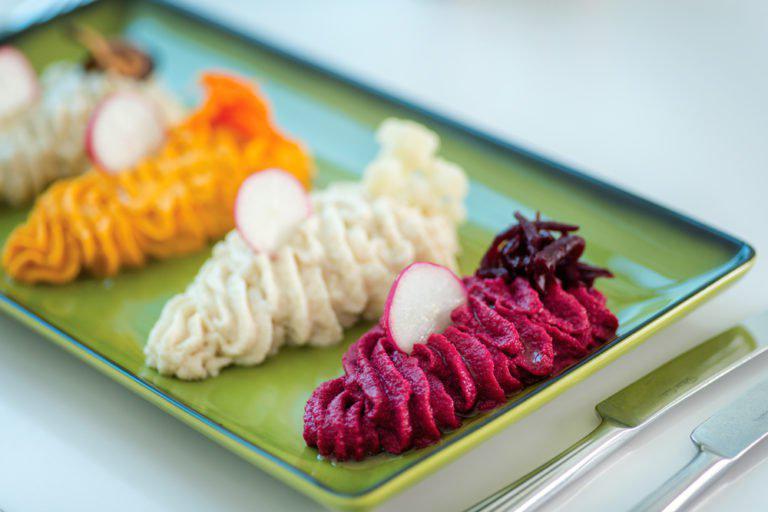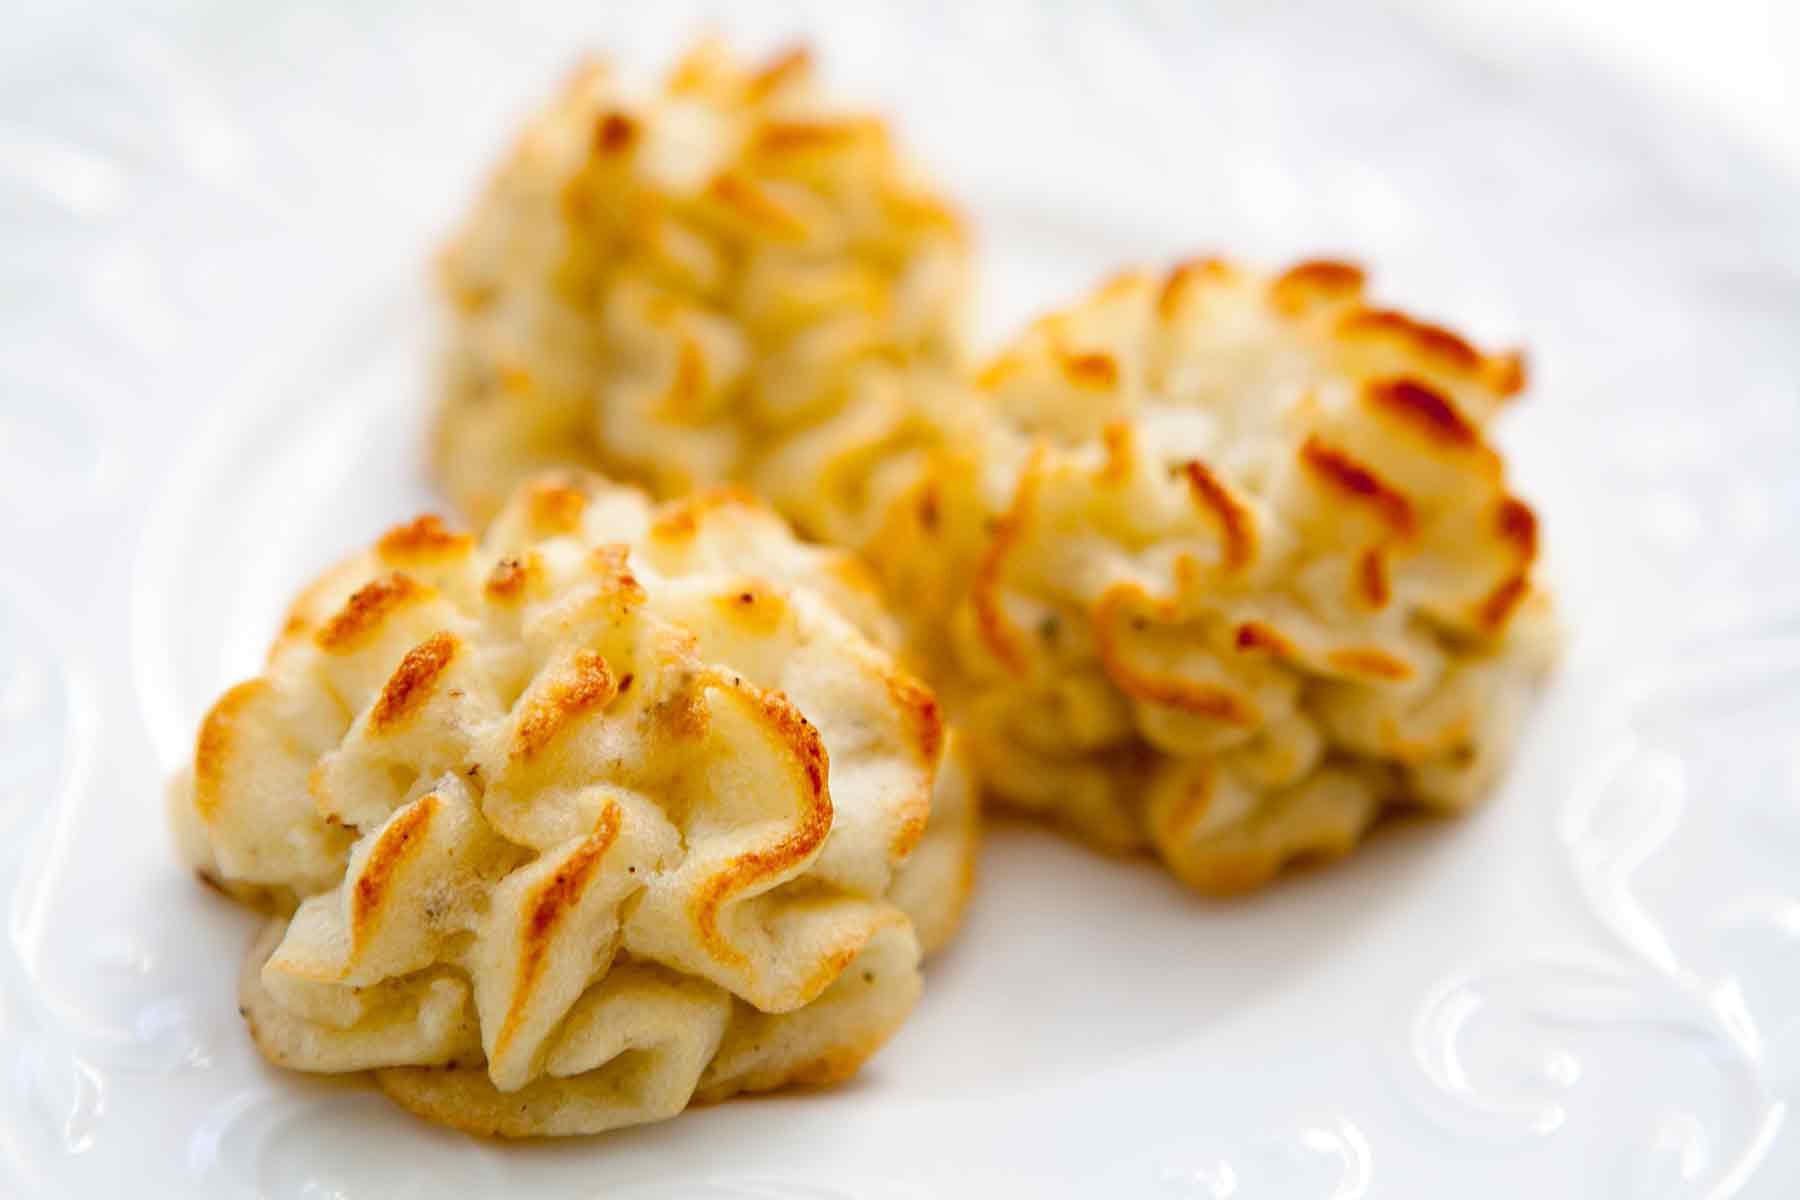The first image is the image on the left, the second image is the image on the right. Assess this claim about the two images: "At least one of the mashed potatoes is not the traditional yellow/orange color.". Correct or not? Answer yes or no. Yes. 